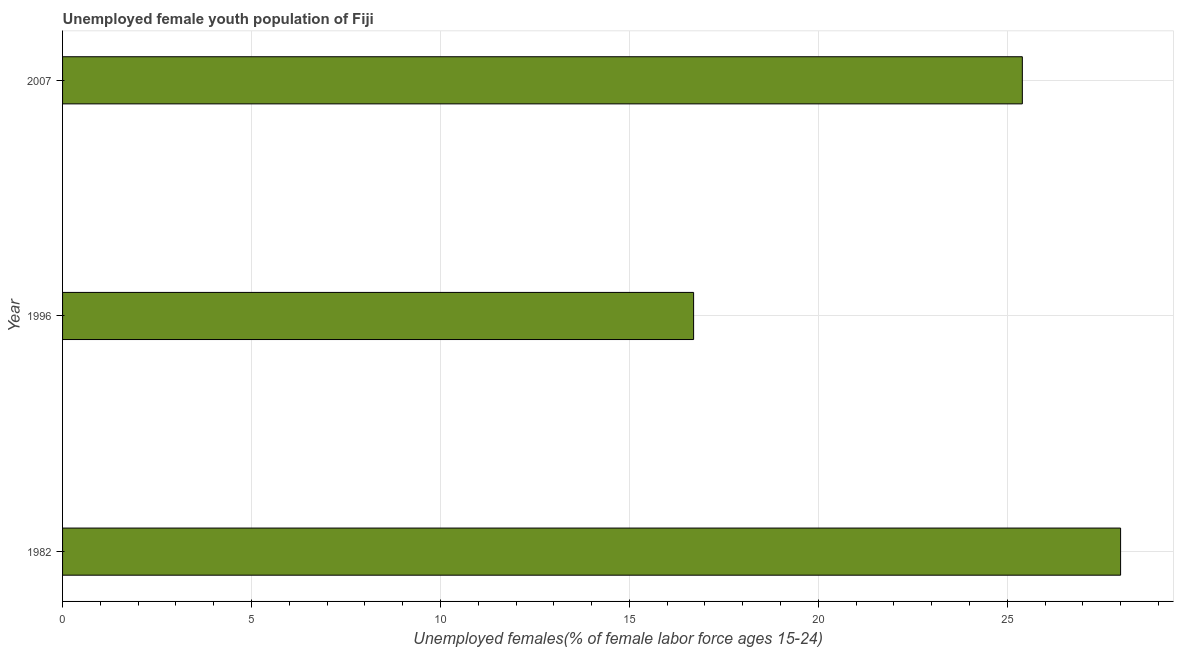Does the graph contain grids?
Your answer should be compact. Yes. What is the title of the graph?
Ensure brevity in your answer.  Unemployed female youth population of Fiji. What is the label or title of the X-axis?
Offer a terse response. Unemployed females(% of female labor force ages 15-24). What is the label or title of the Y-axis?
Make the answer very short. Year. What is the unemployed female youth in 1996?
Your answer should be very brief. 16.7. Across all years, what is the maximum unemployed female youth?
Offer a very short reply. 28. Across all years, what is the minimum unemployed female youth?
Ensure brevity in your answer.  16.7. In which year was the unemployed female youth maximum?
Your response must be concise. 1982. In which year was the unemployed female youth minimum?
Ensure brevity in your answer.  1996. What is the sum of the unemployed female youth?
Your answer should be very brief. 70.1. What is the difference between the unemployed female youth in 1996 and 2007?
Your answer should be compact. -8.7. What is the average unemployed female youth per year?
Your answer should be compact. 23.37. What is the median unemployed female youth?
Keep it short and to the point. 25.4. In how many years, is the unemployed female youth greater than 23 %?
Offer a very short reply. 2. What is the ratio of the unemployed female youth in 1982 to that in 1996?
Offer a very short reply. 1.68. Is the unemployed female youth in 1996 less than that in 2007?
Offer a very short reply. Yes. Is the difference between the unemployed female youth in 1982 and 2007 greater than the difference between any two years?
Ensure brevity in your answer.  No. What is the difference between the highest and the lowest unemployed female youth?
Provide a short and direct response. 11.3. In how many years, is the unemployed female youth greater than the average unemployed female youth taken over all years?
Ensure brevity in your answer.  2. What is the Unemployed females(% of female labor force ages 15-24) of 1982?
Make the answer very short. 28. What is the Unemployed females(% of female labor force ages 15-24) in 1996?
Give a very brief answer. 16.7. What is the Unemployed females(% of female labor force ages 15-24) of 2007?
Offer a very short reply. 25.4. What is the difference between the Unemployed females(% of female labor force ages 15-24) in 1982 and 2007?
Give a very brief answer. 2.6. What is the difference between the Unemployed females(% of female labor force ages 15-24) in 1996 and 2007?
Offer a terse response. -8.7. What is the ratio of the Unemployed females(% of female labor force ages 15-24) in 1982 to that in 1996?
Keep it short and to the point. 1.68. What is the ratio of the Unemployed females(% of female labor force ages 15-24) in 1982 to that in 2007?
Your answer should be very brief. 1.1. What is the ratio of the Unemployed females(% of female labor force ages 15-24) in 1996 to that in 2007?
Provide a short and direct response. 0.66. 